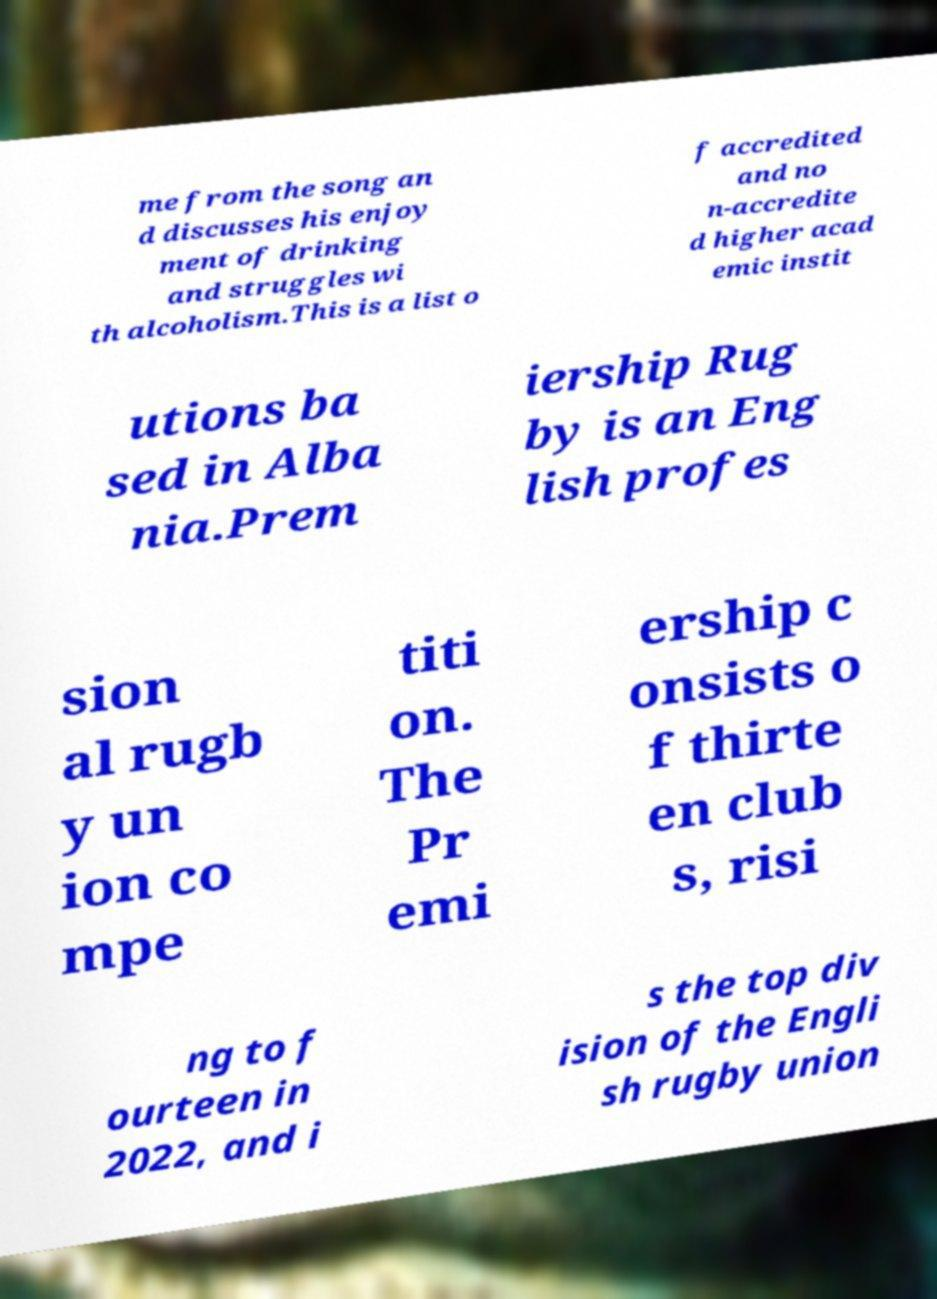I need the written content from this picture converted into text. Can you do that? me from the song an d discusses his enjoy ment of drinking and struggles wi th alcoholism.This is a list o f accredited and no n-accredite d higher acad emic instit utions ba sed in Alba nia.Prem iership Rug by is an Eng lish profes sion al rugb y un ion co mpe titi on. The Pr emi ership c onsists o f thirte en club s, risi ng to f ourteen in 2022, and i s the top div ision of the Engli sh rugby union 